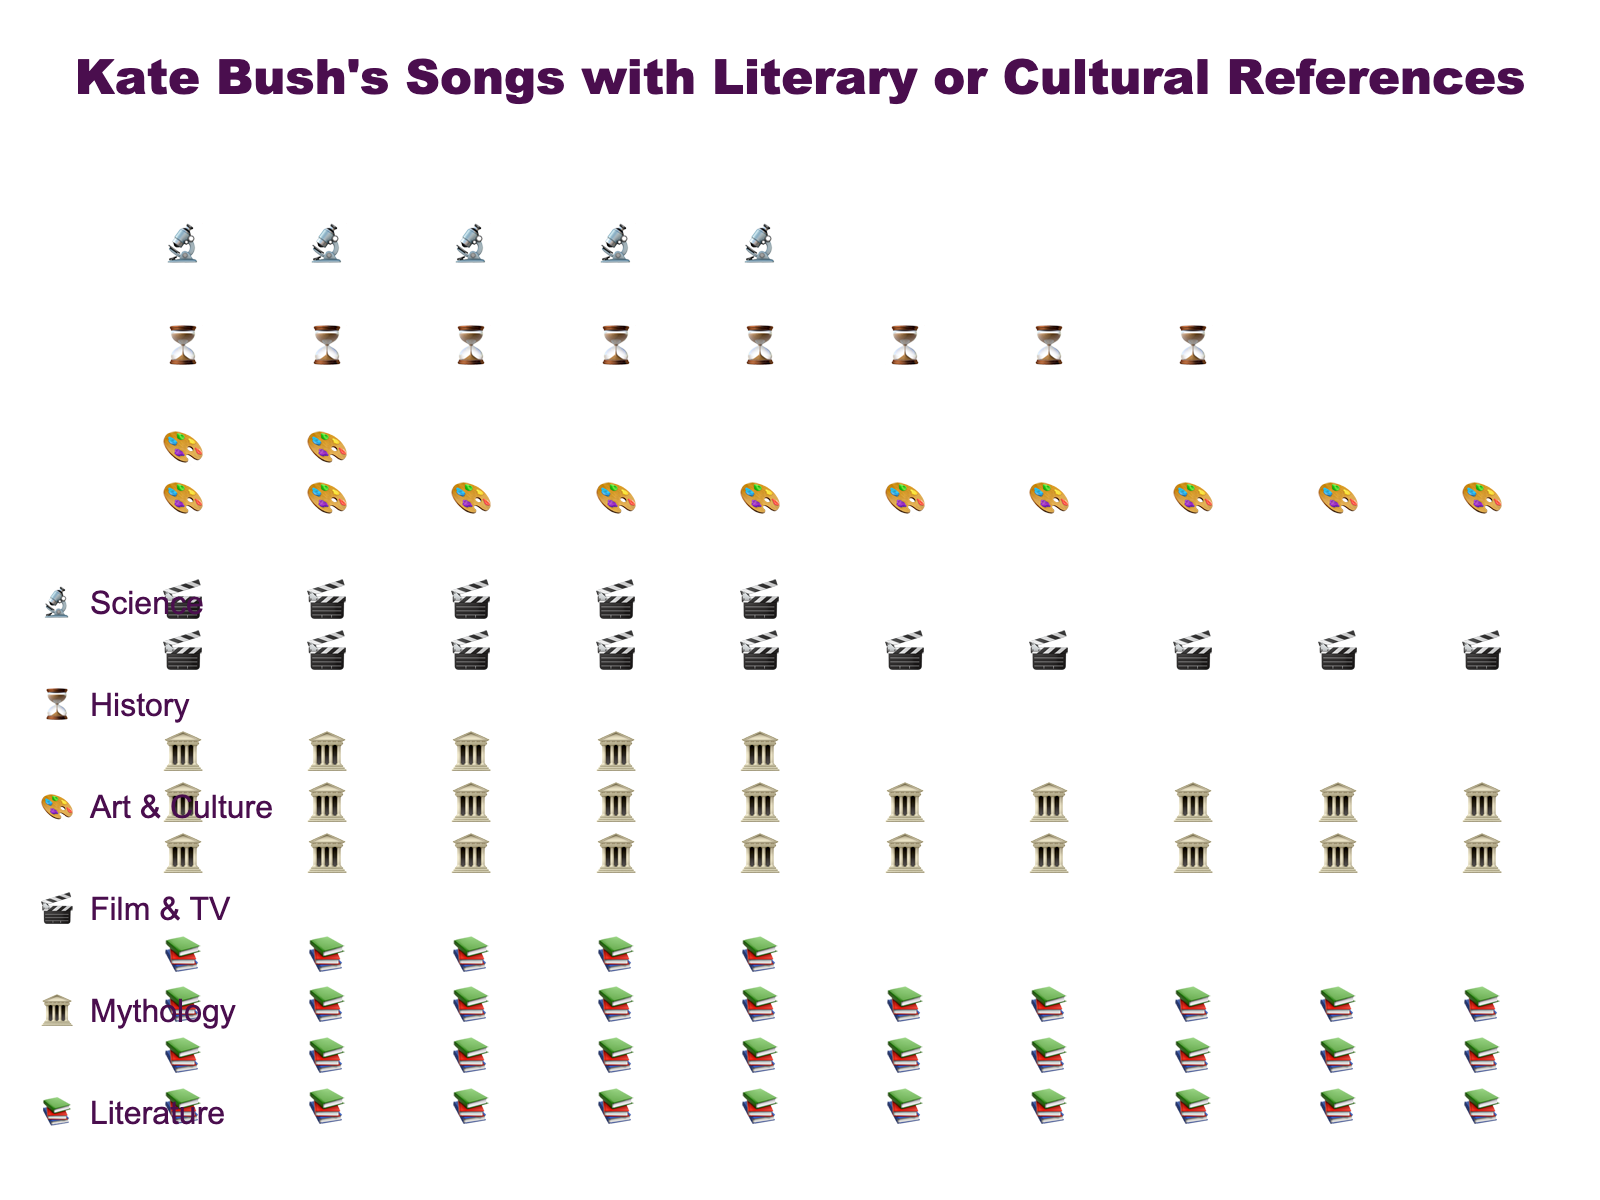What is the proportion of Kate Bush's songs that refer to literature? By looking at the icon representing literature in the proportion data, it shows a value of 0.35
Answer: 0.35 How many songs reference mythology? By looking at the number next to the mythology icon, we see that it is 25 songs.
Answer: 25 Which theme has the smallest representation in Kate Bush's songs? By comparing the counts or proportions, Science has the smallest with a count of 5 and a proportion of 0.05.
Answer: Science What is the sum of songs referring to both Film & TV and Art & Culture? Add the count of songs for Film & TV (15) and Art & Culture (12), resulting in a total of 27
Answer: 27 How does the number of songs referring to Literature compare to those referring to History? Literature has a count of 35 while History has a count of 8; Literature has more songs
Answer: Literature What is the percentage of songs that reference History among all the themes? The figure shows History has a proportion of 0.08, meaning 8% of the songs reference History
Answer: 8% Can you identify the second most referenced theme in Kate Bush's songs? By looking at the counts or proportions, Mythology is second with 25 songs and a proportion of 0.25
Answer: Mythology How many total songs have literary or cultural references in Kate Bush's music? Sum all the counts from each theme: 35 (Literature) + 25 (Mythology) + 15 (Film & TV) + 12 (Art & Culture) + 8 (History) + 5 (Science) = 100
Answer: 100 Which two themes together have a higher combined count than Literature alone? Combining Mythology (25) and Film & TV (15) gives 40, which is higher than Literature's 35; similarly, Mythology and Art & Culture or other pairs could be considered
Answer: Mythology and Film & TV 